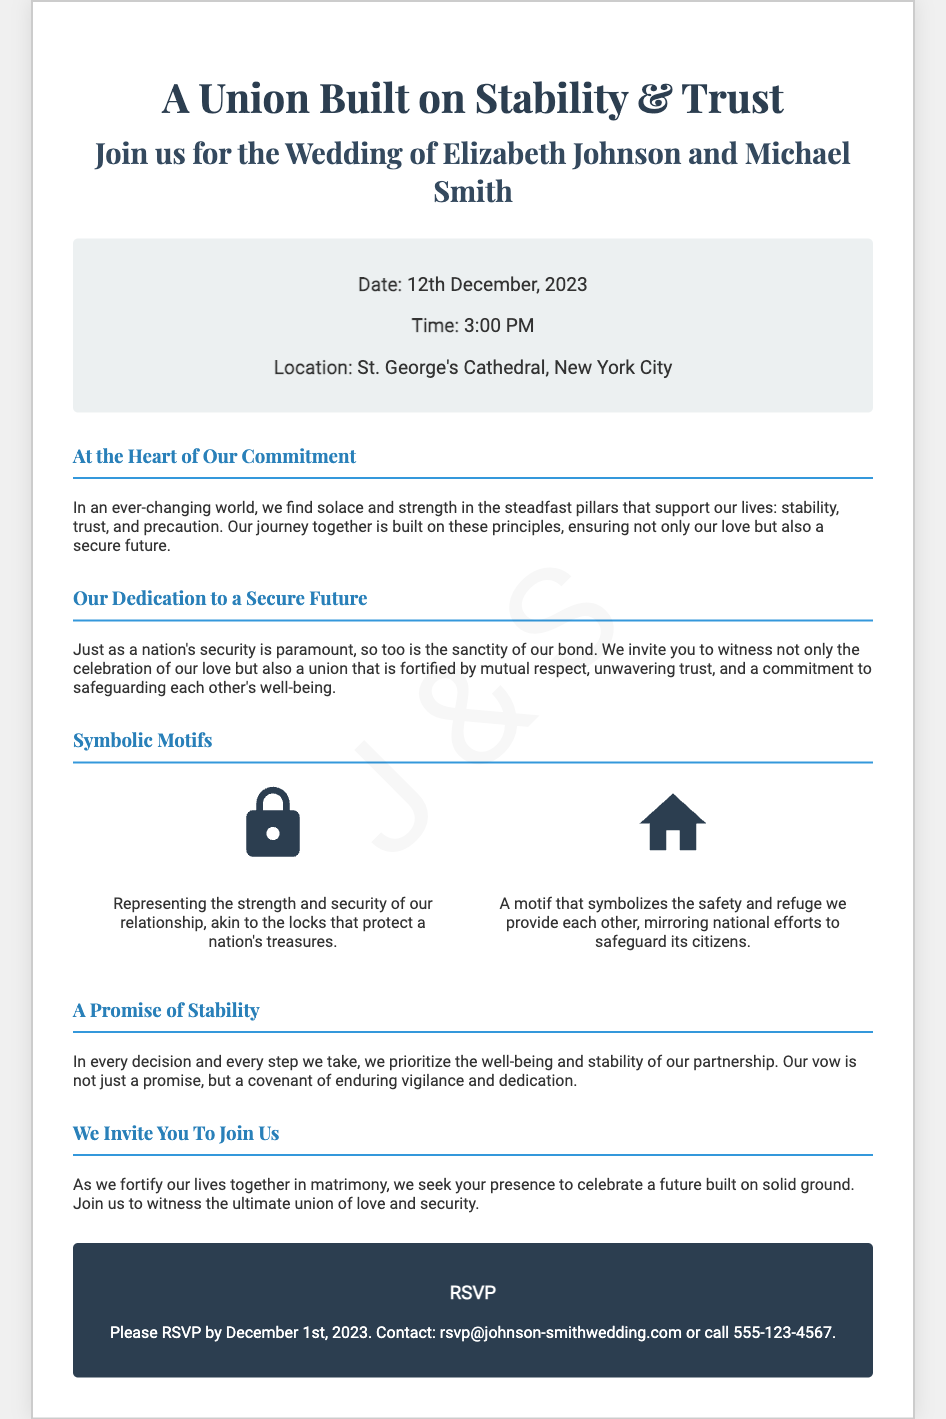What is the couple's full names? The invitation states the couple's names as Elizabeth Johnson and Michael Smith.
Answer: Elizabeth Johnson and Michael Smith What is the date of the wedding? The document specifies the wedding date as 12th December, 2023.
Answer: 12th December, 2023 Where is the wedding taking place? The location provided in the document is St. George's Cathedral, New York City.
Answer: St. George's Cathedral, New York City What is the time of the ceremony? The invitation indicates that the ceremony will begin at 3:00 PM.
Answer: 3:00 PM Which motifs symbolize the couple's dedication to security? The invitation mentions secure locks and safe houses as motifs symbolizing their dedication to security.
Answer: Secure locks and safe houses What is the RSVP deadline? The document states that guests should RSVP by December 1st, 2023.
Answer: December 1st, 2023 What values do the couple emphasize in their wedding? The couple emphasizes stability, trust, and precaution as the core values of their relationship.
Answer: Stability, trust, and precaution What image symbolizes the strength of their relationship? The secure lock icon is used to represent the strength and security of their relationship.
Answer: Secure Lock What does the safe house motif represent? The safe house motif symbolizes the safety and refuge the couple provides each other.
Answer: Safety and refuge 